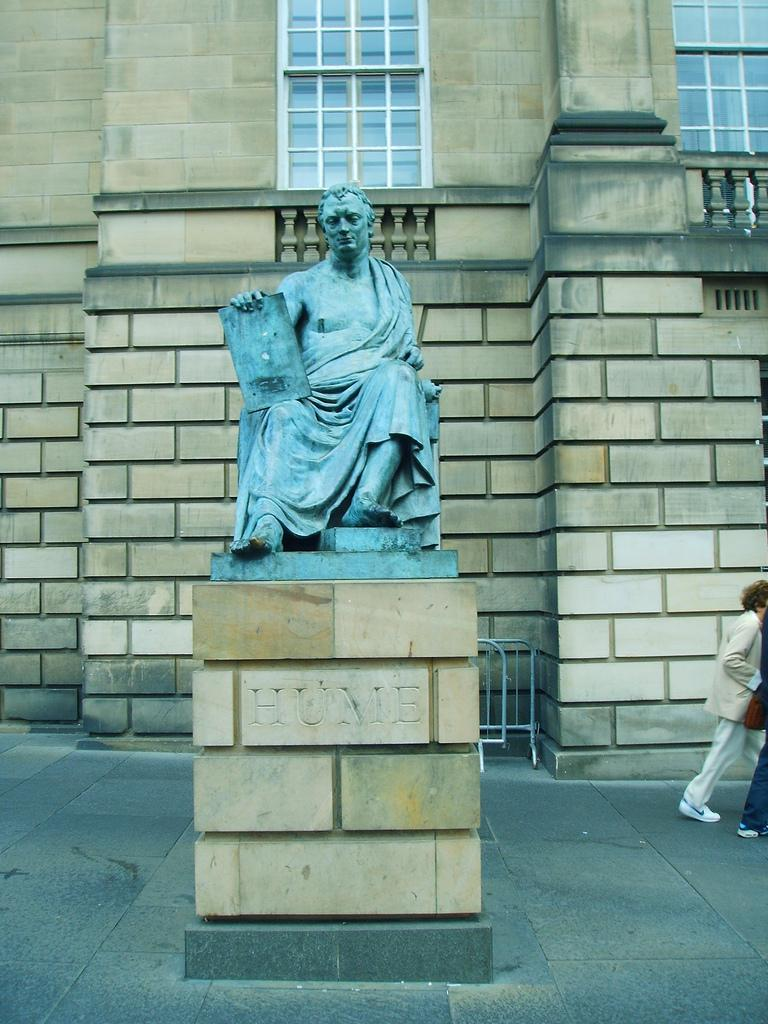What is the main subject of the statue in the image? The statue is of a person sitting and holding an item. How many people are present in the image besides the statue? There are two persons in the image. What can be seen in the image that might be used to control access or movement? There are barriers in the image. What type of structure is visible in the image? There is a building with windows in the image. What is the secretary doing in the image? There is no secretary present in the image. 